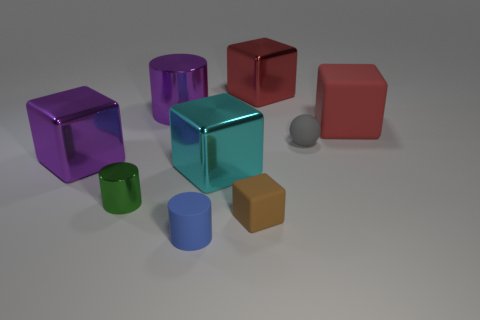What number of other objects are the same shape as the large matte thing?
Your response must be concise. 4. What number of small metallic objects are in front of the red metal block?
Offer a very short reply. 1. What is the size of the shiny thing that is on the right side of the large purple metallic cylinder and behind the big red matte block?
Give a very brief answer. Large. Are there any tiny gray metal cubes?
Offer a terse response. No. What number of other things are there of the same size as the brown matte object?
Provide a succinct answer. 3. Does the large metal cube that is to the left of the small blue cylinder have the same color as the metallic cylinder on the right side of the tiny green object?
Ensure brevity in your answer.  Yes. What size is the purple object that is the same shape as the big cyan metal thing?
Your response must be concise. Large. Do the large purple thing on the left side of the small green metal cylinder and the big red object to the left of the large red rubber thing have the same material?
Your answer should be compact. Yes. What number of matte things are big green blocks or small gray things?
Provide a succinct answer. 1. There is a large thing in front of the block that is left of the small cylinder to the right of the tiny green shiny object; what is it made of?
Make the answer very short. Metal. 